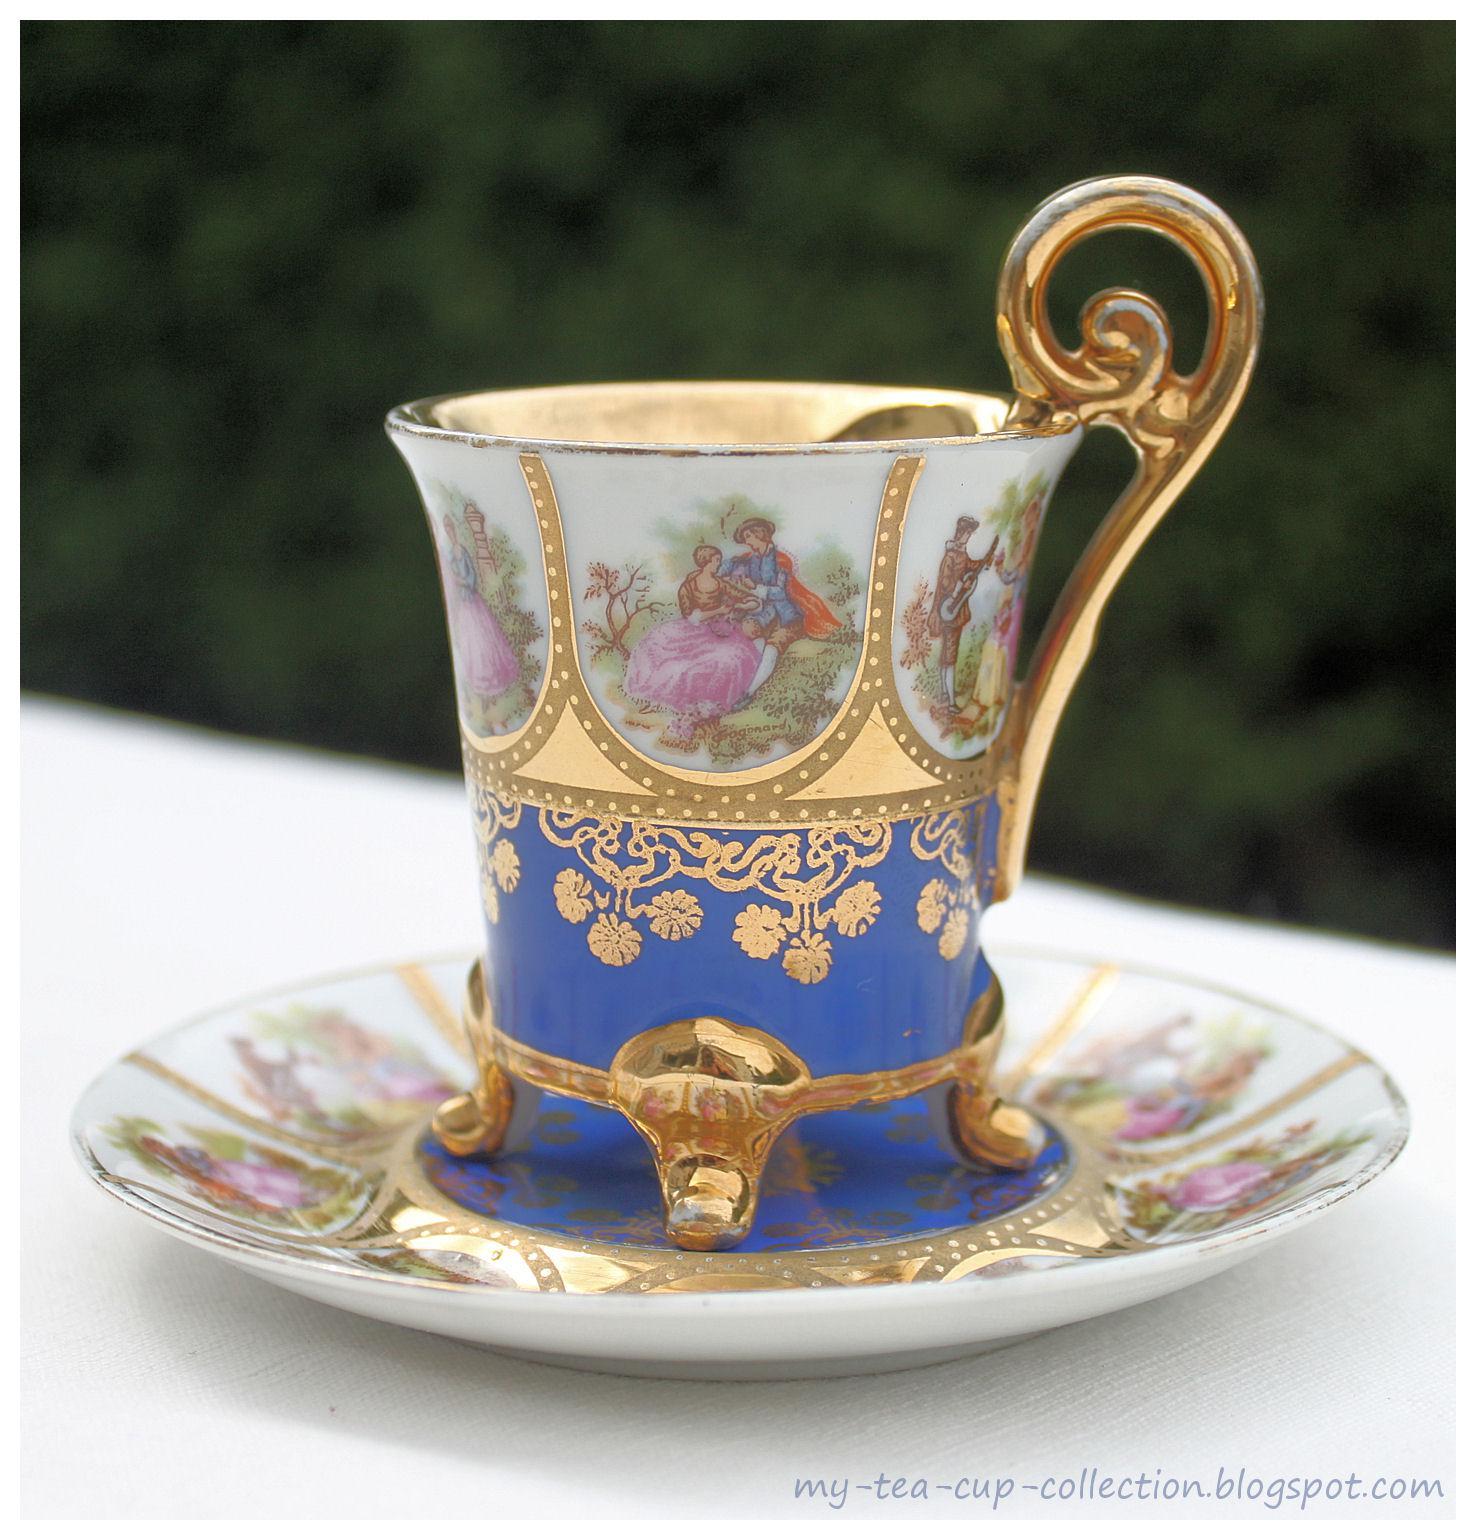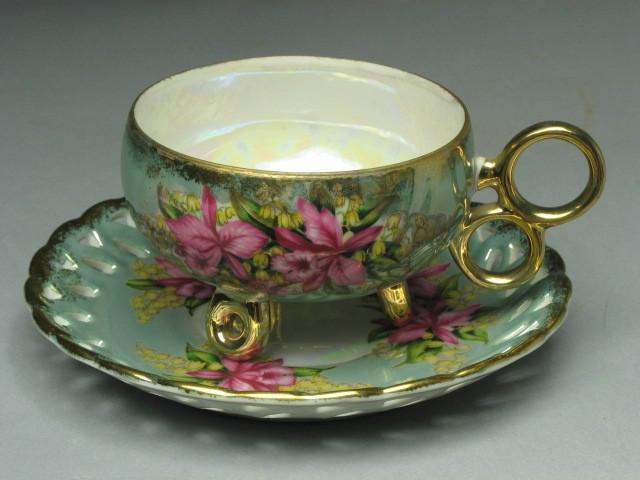The first image is the image on the left, the second image is the image on the right. Assess this claim about the two images: "Both tea cups have curved or curled legs with gold paint.". Correct or not? Answer yes or no. Yes. The first image is the image on the left, the second image is the image on the right. Assess this claim about the two images: "The left image shows a cup and saucer with pink flowers on it.". Correct or not? Answer yes or no. Yes. 